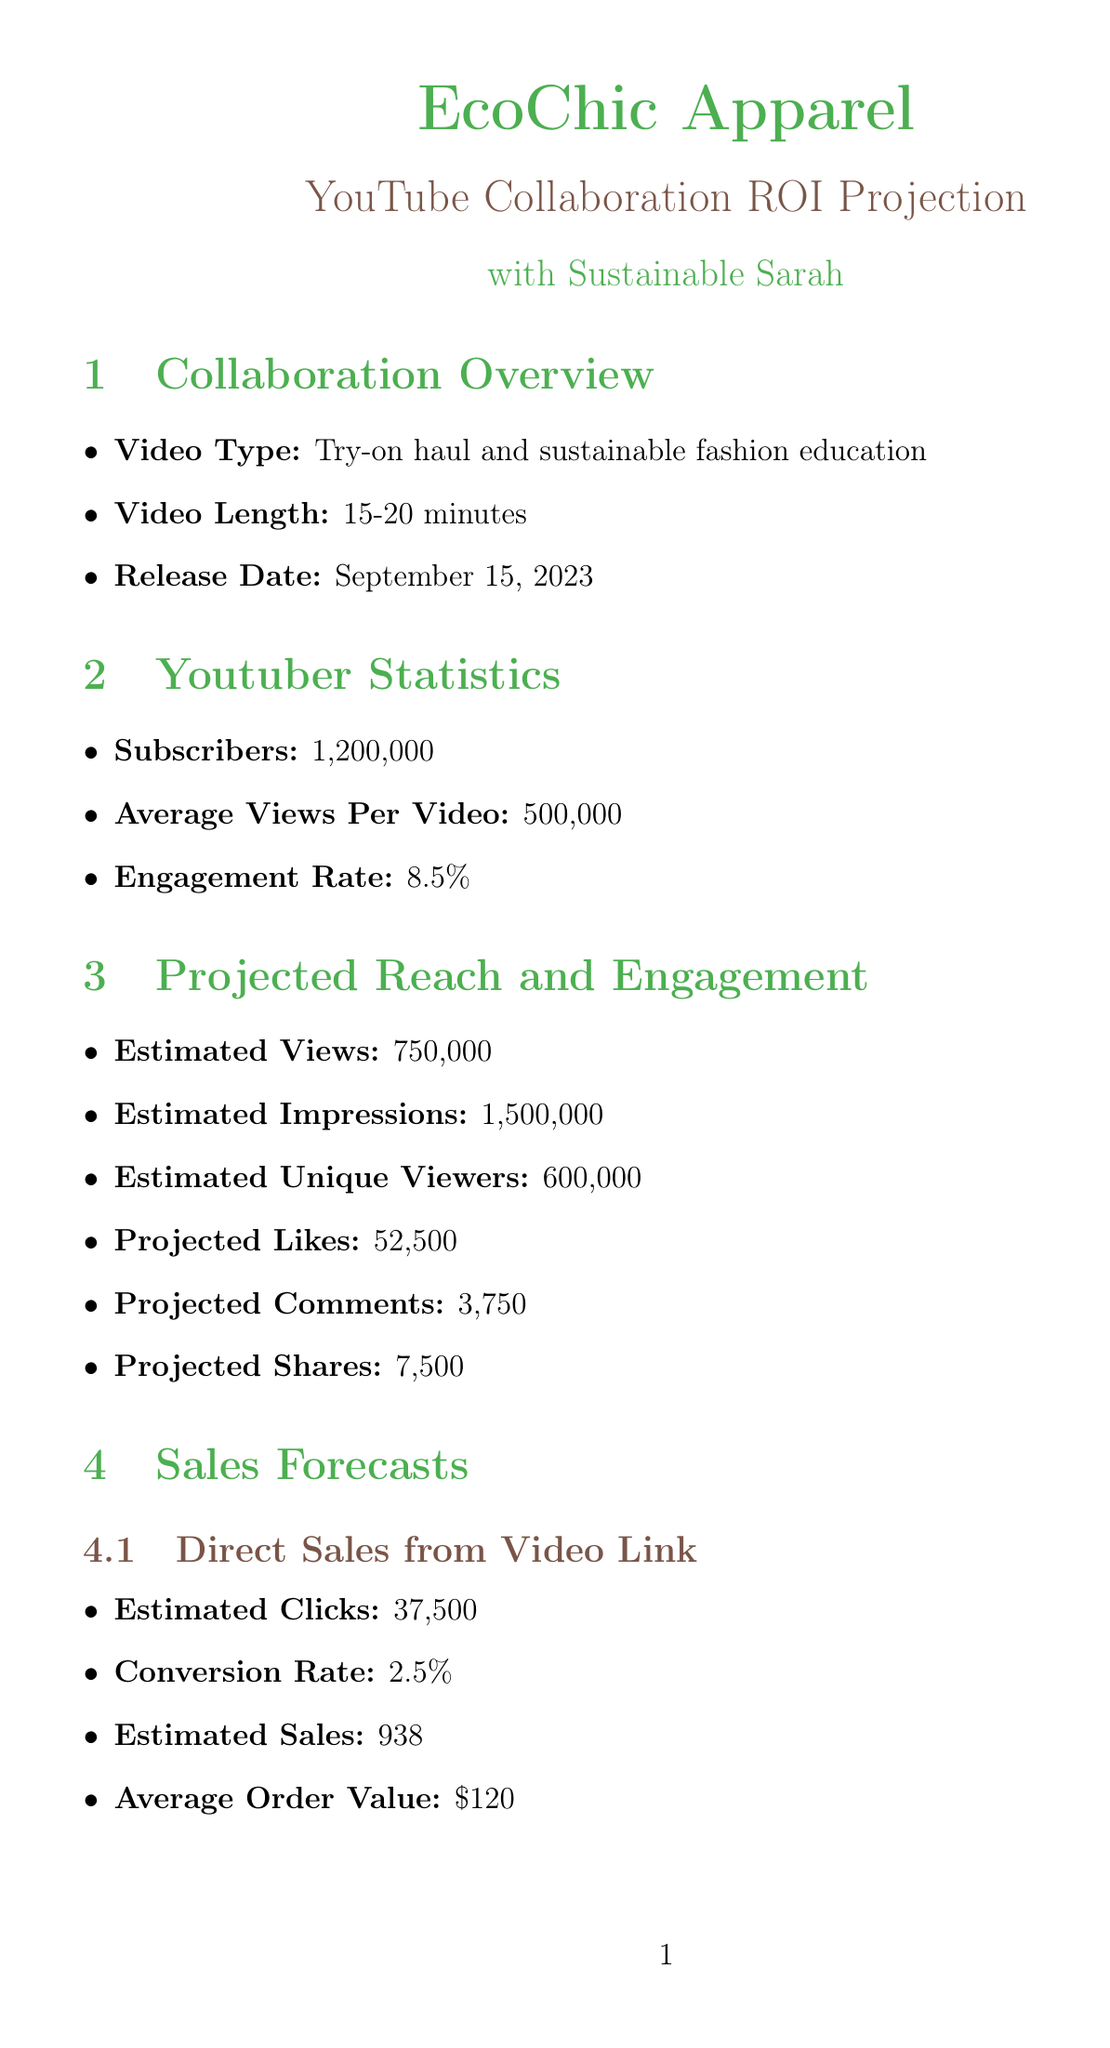What is the name of the brand? The document mentions the brand as EcoChic Apparel.
Answer: EcoChic Apparel What is the estimated number of views for the video? The projected reach section indicates the estimated views are 750,000.
Answer: 750,000 What is the conversion rate for direct sales from the video link? The sales forecasts section states the conversion rate is 2.5%.
Answer: 2.5% What is the projected ROI for the collaboration? The financial projections section lists the projected ROI as 2150%.
Answer: 2150% When is the video scheduled to be released? The collaboration details specify the release date as September 15, 2023.
Answer: September 15, 2023 What is the average order value forecasted? The sales forecasts indicate the average order value is $120.
Answer: $120 How many projected likes are expected from the video? The engagement metrics section shows the projected likes to be 52,500.
Answer: 52,500 What are the potential challenges identified in the risk assessment? The document lists lower than expected view count, technical issues, and negative comments as challenges.
Answer: Lower than expected view count, technical issues, negative comments What are the long-term benefits of this collaboration? The long-term benefits section outlines increased brand awareness, improved brand image, and ongoing collaboration potential.
Answer: Increased brand awareness, improved brand image, ongoing collaboration 